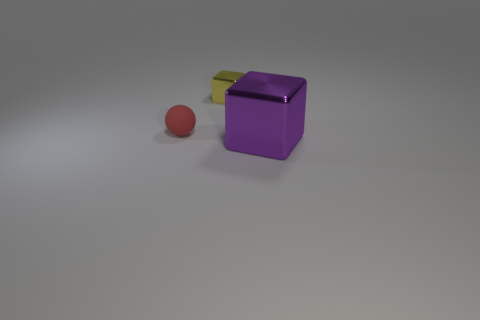Add 3 big objects. How many objects exist? 6 Subtract all blocks. How many objects are left? 1 Subtract all tiny metal blocks. Subtract all large purple metallic cubes. How many objects are left? 1 Add 1 red objects. How many red objects are left? 2 Add 2 tiny yellow metal blocks. How many tiny yellow metal blocks exist? 3 Subtract 0 blue spheres. How many objects are left? 3 